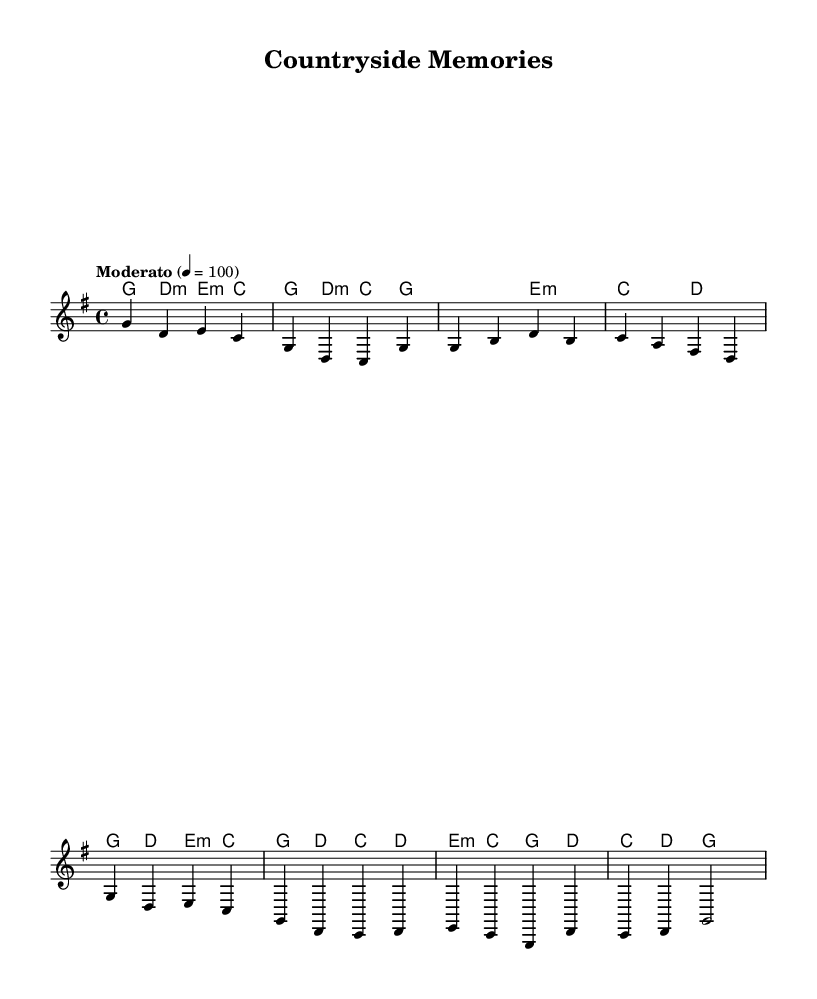What is the key signature of this music? The key signature is G major, which has one sharp (F#). You can identify the key signature by looking at the beginning of the music sheet where it is indicated.
Answer: G major What is the time signature of this music? The time signature is 4/4, meaning there are four beats in each measure, and a quarter note gets one beat. This can be found at the beginning of the music sheet where the time signature is indicated.
Answer: 4/4 What tempo marking is used in this music? The tempo marking indicates "Moderato" with a speed of quarter note equals 100 beats per minute. This is found near the top of the score, showing how fast the piece should be played.
Answer: Moderato What are the first three notes in the melody? The first three notes are G, D, and E. You can find these notes at the beginning of the melody section, which starts with the pitches in the specified order.
Answer: G, D, E What is the chord associated with the first measure's melody note? The chord associated with the first measure's melody note (G) is G major. This can be determined by looking at the chord symbols directly above the melody notes at the start of the measures.
Answer: G major How many measures are there in the chorus section? There are four measures in the chorus section. You can count the measures in the chorus part of the score after looking at the grouping of the melody and chord markings.
Answer: Four What is the last chord in the score? The last chord in the score is G major. This can be found by looking at the final chord symbol in the score, which indicates the harmony that concludes the piece.
Answer: G major 